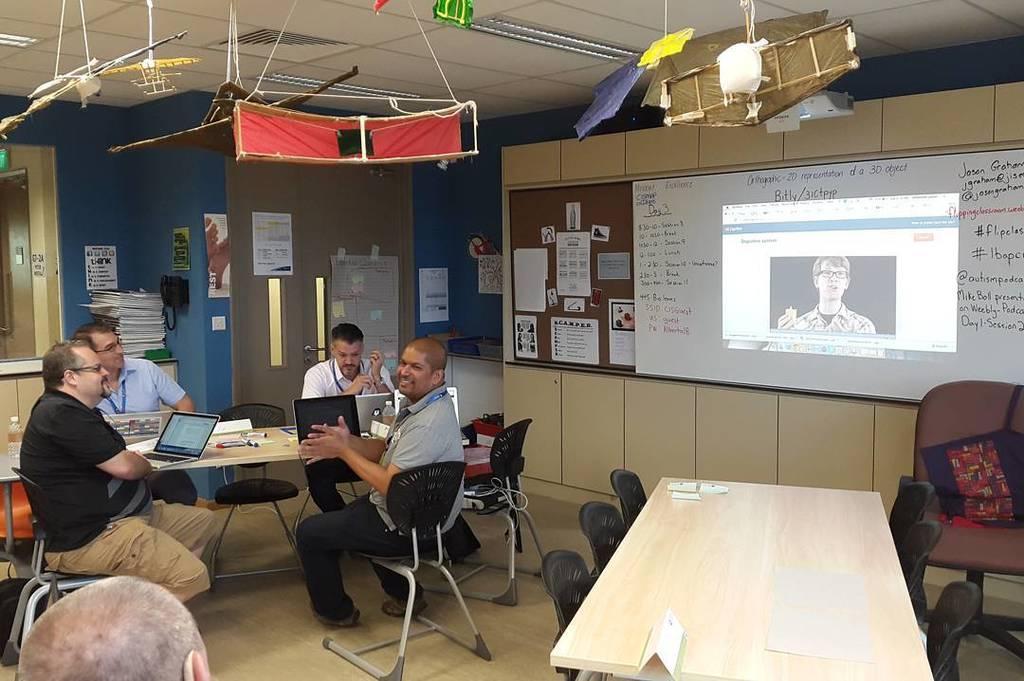Could you give a brief overview of what you see in this image? There are four people sitting on the chairs. This is the table with a laptop's,papers,marker pens and few other objects on it. I can see another wooden table with a name board and paper on it. These are the empty chairs. This is a screen. This looks like a projector which is attached to the rooftop. I can see few objects hanging. This is the white board attached to the wall. These are the posters attached to the notice board. This looks like a door with a door handle. I can see few books here. At the bottom left corner I can see the person head. These are the ceiling lights attached to the rooftop. 